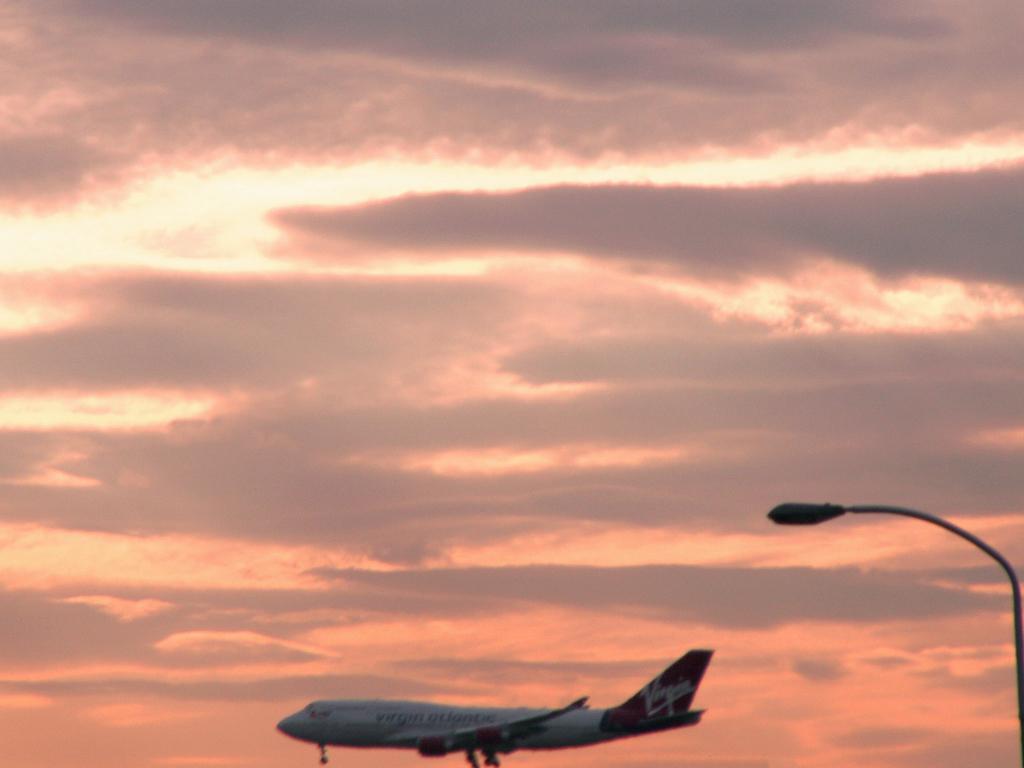Could you give a brief overview of what you see in this image? In this image there is a airplane, in the right side there is a light pole, in the background there is a sky. 